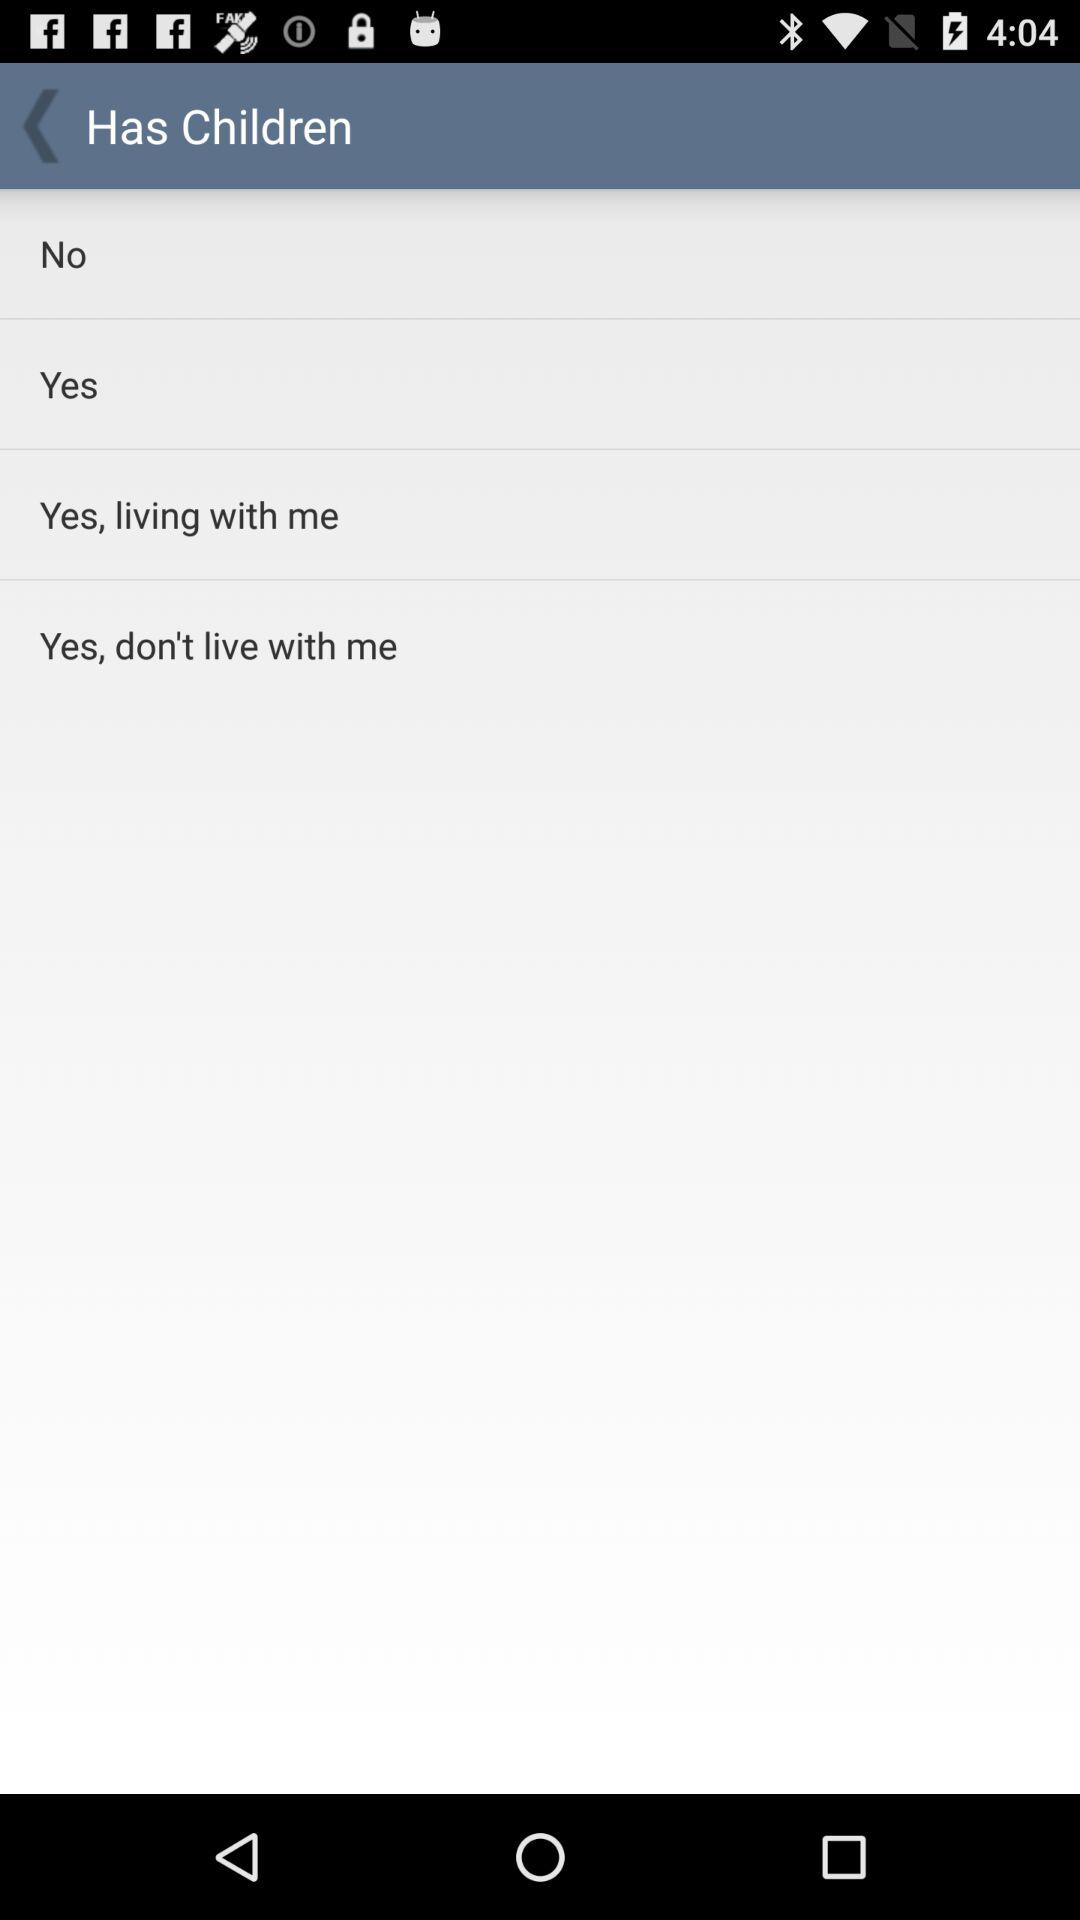How many options are there for the children question?
Answer the question using a single word or phrase. 4 